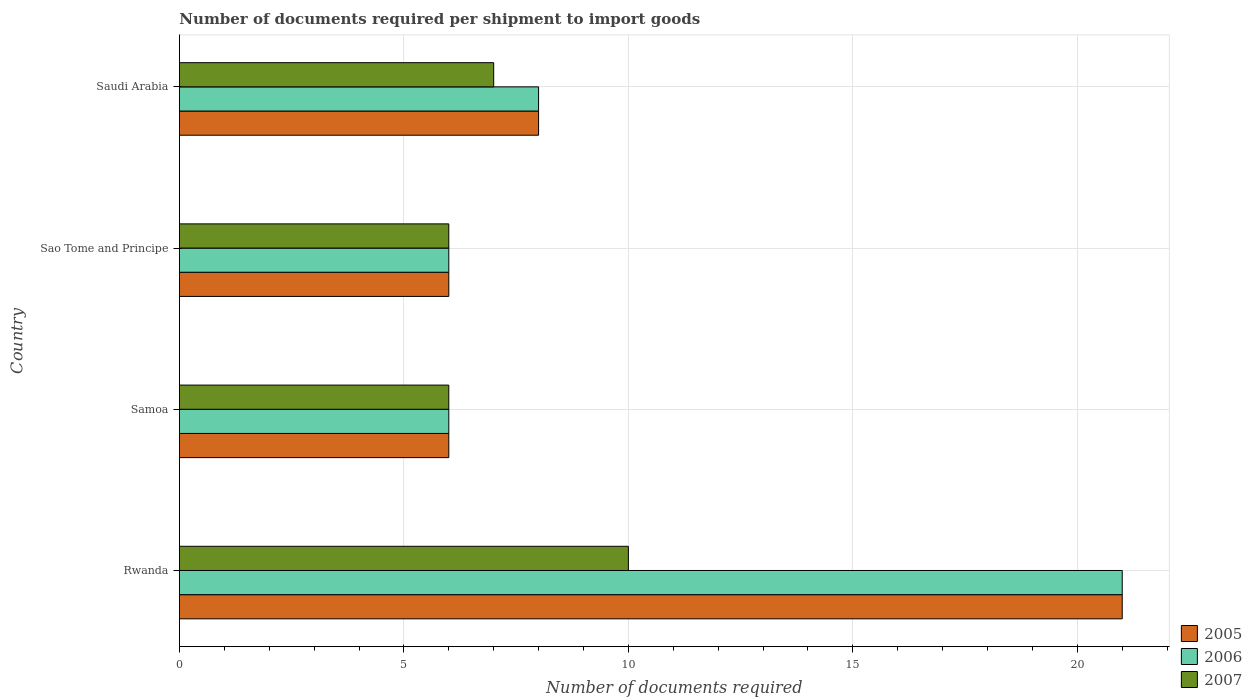How many different coloured bars are there?
Your response must be concise. 3. How many groups of bars are there?
Make the answer very short. 4. Are the number of bars on each tick of the Y-axis equal?
Offer a terse response. Yes. What is the label of the 1st group of bars from the top?
Your response must be concise. Saudi Arabia. What is the number of documents required per shipment to import goods in 2005 in Samoa?
Give a very brief answer. 6. Across all countries, what is the minimum number of documents required per shipment to import goods in 2006?
Provide a short and direct response. 6. In which country was the number of documents required per shipment to import goods in 2006 maximum?
Provide a succinct answer. Rwanda. In which country was the number of documents required per shipment to import goods in 2007 minimum?
Offer a terse response. Samoa. What is the average number of documents required per shipment to import goods in 2005 per country?
Offer a very short reply. 10.25. In how many countries, is the number of documents required per shipment to import goods in 2005 greater than 19 ?
Keep it short and to the point. 1. Is the number of documents required per shipment to import goods in 2007 in Sao Tome and Principe less than that in Saudi Arabia?
Your answer should be very brief. Yes. What is the difference between the highest and the second highest number of documents required per shipment to import goods in 2006?
Keep it short and to the point. 13. In how many countries, is the number of documents required per shipment to import goods in 2007 greater than the average number of documents required per shipment to import goods in 2007 taken over all countries?
Provide a succinct answer. 1. Is the sum of the number of documents required per shipment to import goods in 2007 in Samoa and Saudi Arabia greater than the maximum number of documents required per shipment to import goods in 2006 across all countries?
Keep it short and to the point. No. Are all the bars in the graph horizontal?
Ensure brevity in your answer.  Yes. How many countries are there in the graph?
Your answer should be very brief. 4. Are the values on the major ticks of X-axis written in scientific E-notation?
Ensure brevity in your answer.  No. Does the graph contain any zero values?
Provide a succinct answer. No. Does the graph contain grids?
Make the answer very short. Yes. Where does the legend appear in the graph?
Provide a short and direct response. Bottom right. How are the legend labels stacked?
Ensure brevity in your answer.  Vertical. What is the title of the graph?
Provide a succinct answer. Number of documents required per shipment to import goods. What is the label or title of the X-axis?
Offer a very short reply. Number of documents required. What is the Number of documents required in 2006 in Samoa?
Your answer should be compact. 6. What is the Number of documents required in 2005 in Sao Tome and Principe?
Provide a succinct answer. 6. What is the Number of documents required of 2006 in Sao Tome and Principe?
Your answer should be very brief. 6. What is the Number of documents required of 2006 in Saudi Arabia?
Give a very brief answer. 8. Across all countries, what is the maximum Number of documents required of 2005?
Give a very brief answer. 21. Across all countries, what is the maximum Number of documents required in 2006?
Your answer should be very brief. 21. Across all countries, what is the maximum Number of documents required of 2007?
Provide a succinct answer. 10. Across all countries, what is the minimum Number of documents required of 2006?
Offer a very short reply. 6. What is the total Number of documents required in 2007 in the graph?
Your answer should be compact. 29. What is the difference between the Number of documents required in 2005 in Rwanda and that in Samoa?
Provide a succinct answer. 15. What is the difference between the Number of documents required in 2006 in Rwanda and that in Samoa?
Your answer should be very brief. 15. What is the difference between the Number of documents required in 2007 in Rwanda and that in Samoa?
Ensure brevity in your answer.  4. What is the difference between the Number of documents required in 2005 in Rwanda and that in Sao Tome and Principe?
Make the answer very short. 15. What is the difference between the Number of documents required in 2005 in Rwanda and that in Saudi Arabia?
Provide a short and direct response. 13. What is the difference between the Number of documents required of 2006 in Rwanda and that in Saudi Arabia?
Ensure brevity in your answer.  13. What is the difference between the Number of documents required in 2007 in Rwanda and that in Saudi Arabia?
Keep it short and to the point. 3. What is the difference between the Number of documents required in 2005 in Samoa and that in Sao Tome and Principe?
Give a very brief answer. 0. What is the difference between the Number of documents required in 2006 in Samoa and that in Sao Tome and Principe?
Keep it short and to the point. 0. What is the difference between the Number of documents required of 2006 in Samoa and that in Saudi Arabia?
Provide a succinct answer. -2. What is the difference between the Number of documents required of 2007 in Samoa and that in Saudi Arabia?
Keep it short and to the point. -1. What is the difference between the Number of documents required in 2006 in Sao Tome and Principe and that in Saudi Arabia?
Provide a short and direct response. -2. What is the difference between the Number of documents required of 2007 in Sao Tome and Principe and that in Saudi Arabia?
Your answer should be compact. -1. What is the difference between the Number of documents required in 2005 in Rwanda and the Number of documents required in 2006 in Sao Tome and Principe?
Your answer should be compact. 15. What is the difference between the Number of documents required in 2005 in Rwanda and the Number of documents required in 2007 in Sao Tome and Principe?
Provide a short and direct response. 15. What is the difference between the Number of documents required of 2006 in Rwanda and the Number of documents required of 2007 in Sao Tome and Principe?
Give a very brief answer. 15. What is the difference between the Number of documents required of 2005 in Rwanda and the Number of documents required of 2007 in Saudi Arabia?
Your answer should be very brief. 14. What is the difference between the Number of documents required of 2005 in Samoa and the Number of documents required of 2006 in Saudi Arabia?
Provide a succinct answer. -2. What is the difference between the Number of documents required in 2006 in Samoa and the Number of documents required in 2007 in Saudi Arabia?
Give a very brief answer. -1. What is the average Number of documents required in 2005 per country?
Provide a short and direct response. 10.25. What is the average Number of documents required in 2006 per country?
Provide a short and direct response. 10.25. What is the average Number of documents required in 2007 per country?
Give a very brief answer. 7.25. What is the difference between the Number of documents required of 2006 and Number of documents required of 2007 in Rwanda?
Make the answer very short. 11. What is the difference between the Number of documents required of 2005 and Number of documents required of 2007 in Samoa?
Offer a terse response. 0. What is the difference between the Number of documents required of 2006 and Number of documents required of 2007 in Samoa?
Ensure brevity in your answer.  0. What is the difference between the Number of documents required of 2005 and Number of documents required of 2006 in Saudi Arabia?
Provide a succinct answer. 0. What is the ratio of the Number of documents required of 2005 in Rwanda to that in Samoa?
Your answer should be compact. 3.5. What is the ratio of the Number of documents required in 2005 in Rwanda to that in Sao Tome and Principe?
Your answer should be compact. 3.5. What is the ratio of the Number of documents required of 2006 in Rwanda to that in Sao Tome and Principe?
Provide a succinct answer. 3.5. What is the ratio of the Number of documents required of 2005 in Rwanda to that in Saudi Arabia?
Offer a very short reply. 2.62. What is the ratio of the Number of documents required of 2006 in Rwanda to that in Saudi Arabia?
Make the answer very short. 2.62. What is the ratio of the Number of documents required of 2007 in Rwanda to that in Saudi Arabia?
Your response must be concise. 1.43. What is the ratio of the Number of documents required of 2005 in Samoa to that in Saudi Arabia?
Provide a succinct answer. 0.75. What is the ratio of the Number of documents required of 2005 in Sao Tome and Principe to that in Saudi Arabia?
Ensure brevity in your answer.  0.75. What is the ratio of the Number of documents required in 2006 in Sao Tome and Principe to that in Saudi Arabia?
Give a very brief answer. 0.75. What is the difference between the highest and the second highest Number of documents required of 2005?
Make the answer very short. 13. What is the difference between the highest and the second highest Number of documents required of 2007?
Your answer should be very brief. 3. What is the difference between the highest and the lowest Number of documents required of 2005?
Your answer should be compact. 15. 